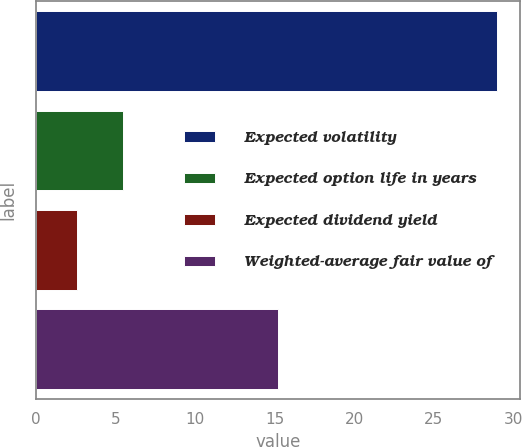<chart> <loc_0><loc_0><loc_500><loc_500><bar_chart><fcel>Expected volatility<fcel>Expected option life in years<fcel>Expected dividend yield<fcel>Weighted-average fair value of<nl><fcel>29<fcel>5.5<fcel>2.6<fcel>15.25<nl></chart> 